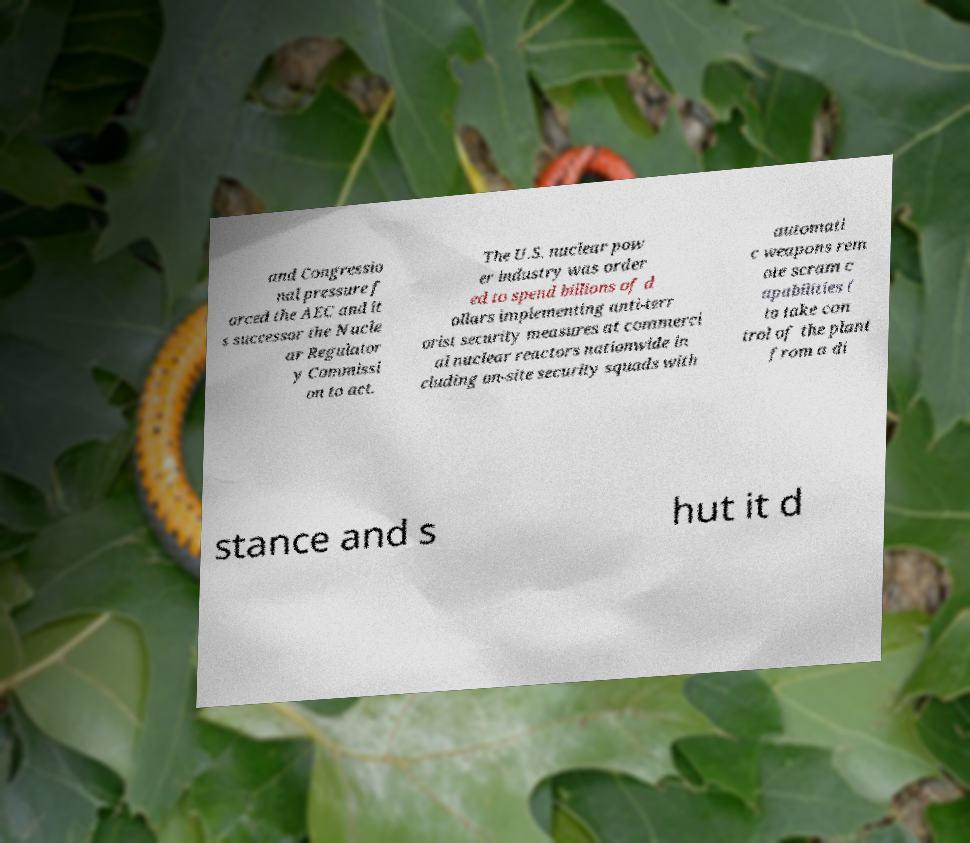Can you read and provide the text displayed in the image?This photo seems to have some interesting text. Can you extract and type it out for me? and Congressio nal pressure f orced the AEC and it s successor the Nucle ar Regulator y Commissi on to act. The U.S. nuclear pow er industry was order ed to spend billions of d ollars implementing anti-terr orist security measures at commerci al nuclear reactors nationwide in cluding on-site security squads with automati c weapons rem ote scram c apabilities ( to take con trol of the plant from a di stance and s hut it d 